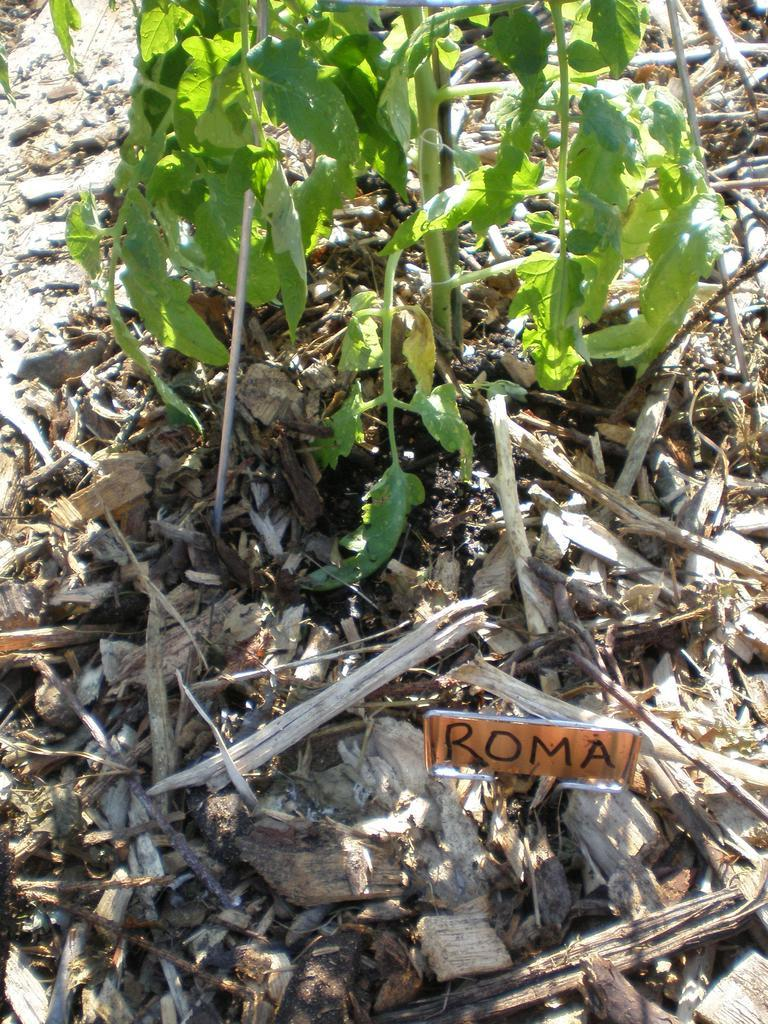What type of living organism can be seen in the image? There is a plant in the image. What material are the sticks made of in the image? The sticks in the image are made of wood. What is the flat, rectangular object in the image? There is a board in the image. What type of error can be seen in the image? There is no error present in the image. Is there a sink visible in the image? There is no sink present in the image. 